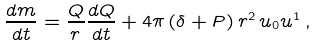Convert formula to latex. <formula><loc_0><loc_0><loc_500><loc_500>\frac { d m } { d t } = \frac { Q } { r } \frac { d Q } { d t } + 4 \pi \, ( \delta + P ) \, r ^ { 2 } \, u _ { 0 } u ^ { 1 } \, ,</formula> 